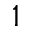Convert formula to latex. <formula><loc_0><loc_0><loc_500><loc_500>1</formula> 